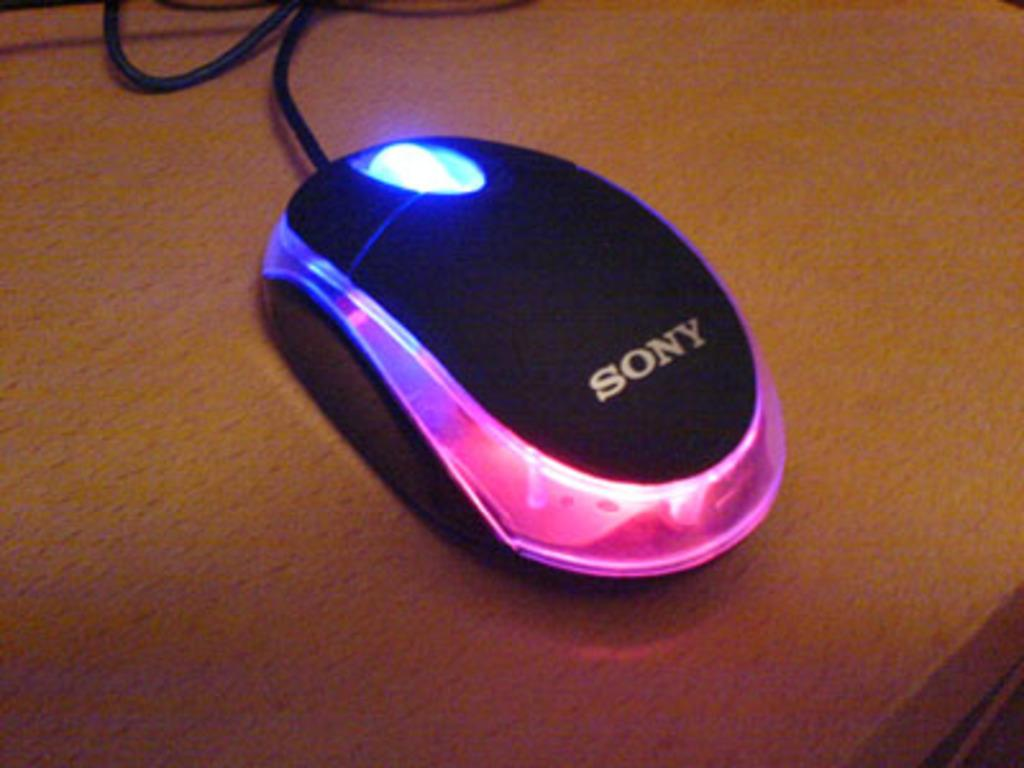What type of animal is in the image? There is a mouse in the image. What surface is the mouse on? The mouse is on a wooden surface. What type of knee injury does the mouse have in the image? There is no indication of a knee injury or any injury in the image; it simply shows a mouse on a wooden surface. 